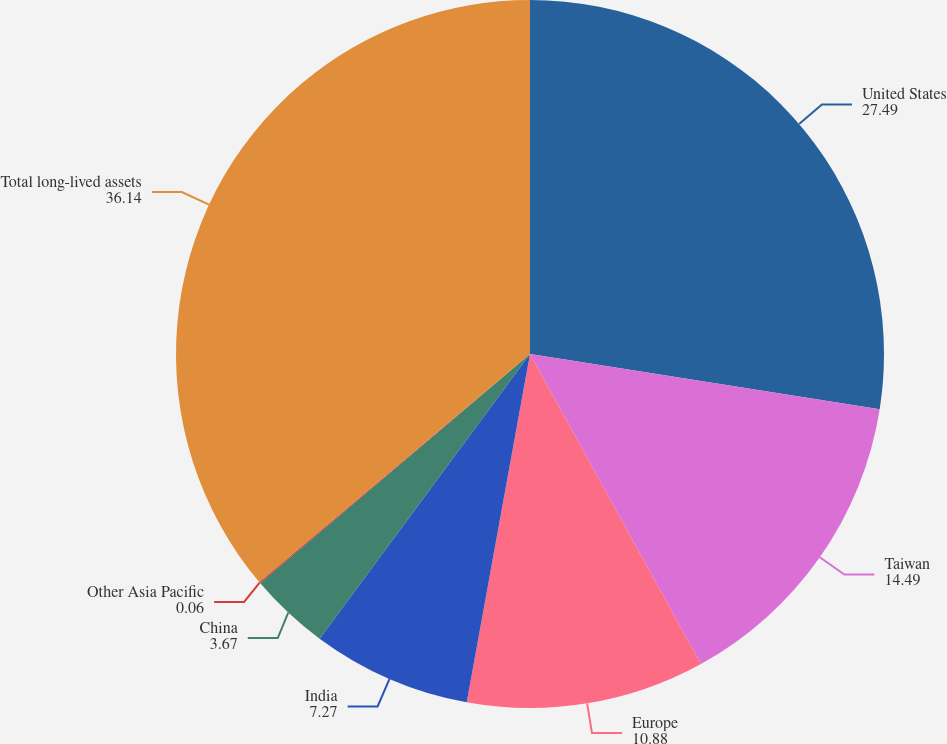Convert chart. <chart><loc_0><loc_0><loc_500><loc_500><pie_chart><fcel>United States<fcel>Taiwan<fcel>Europe<fcel>India<fcel>China<fcel>Other Asia Pacific<fcel>Total long-lived assets<nl><fcel>27.49%<fcel>14.49%<fcel>10.88%<fcel>7.27%<fcel>3.67%<fcel>0.06%<fcel>36.14%<nl></chart> 